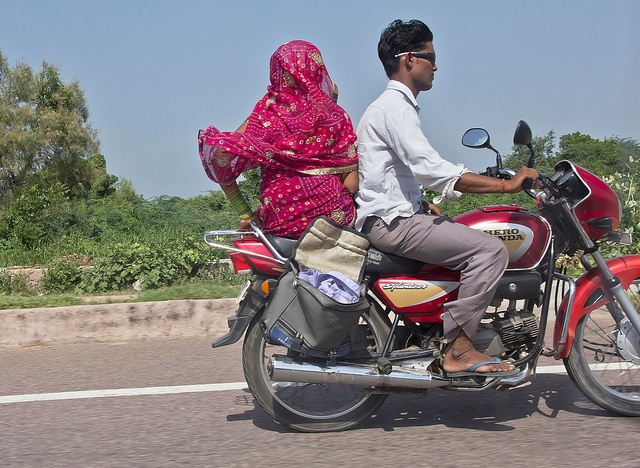Describe the objects in this image and their specific colors. I can see motorcycle in darkgray, gray, black, and maroon tones, people in darkgray, lightgray, gray, and black tones, people in darkgray, brown, and maroon tones, and handbag in darkgray, gray, black, and lightgray tones in this image. 